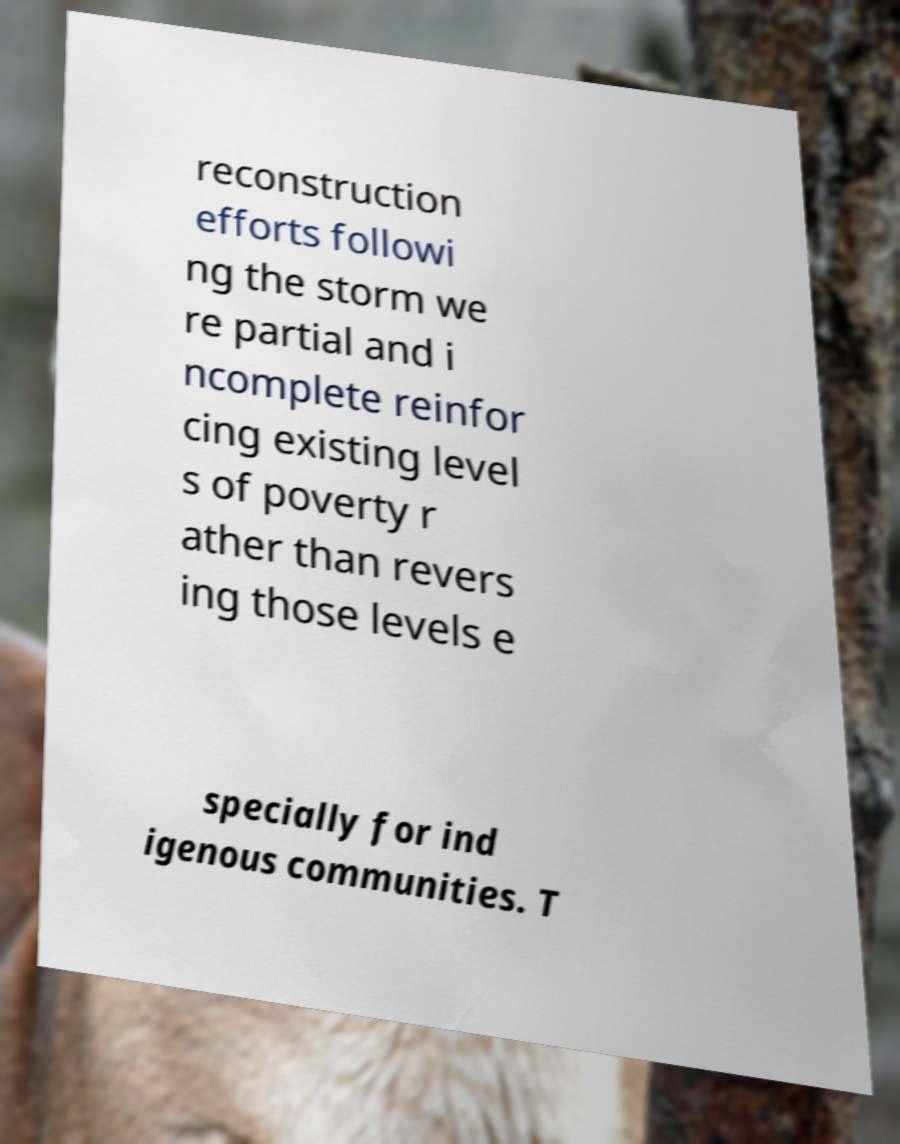Please read and relay the text visible in this image. What does it say? reconstruction efforts followi ng the storm we re partial and i ncomplete reinfor cing existing level s of poverty r ather than revers ing those levels e specially for ind igenous communities. T 